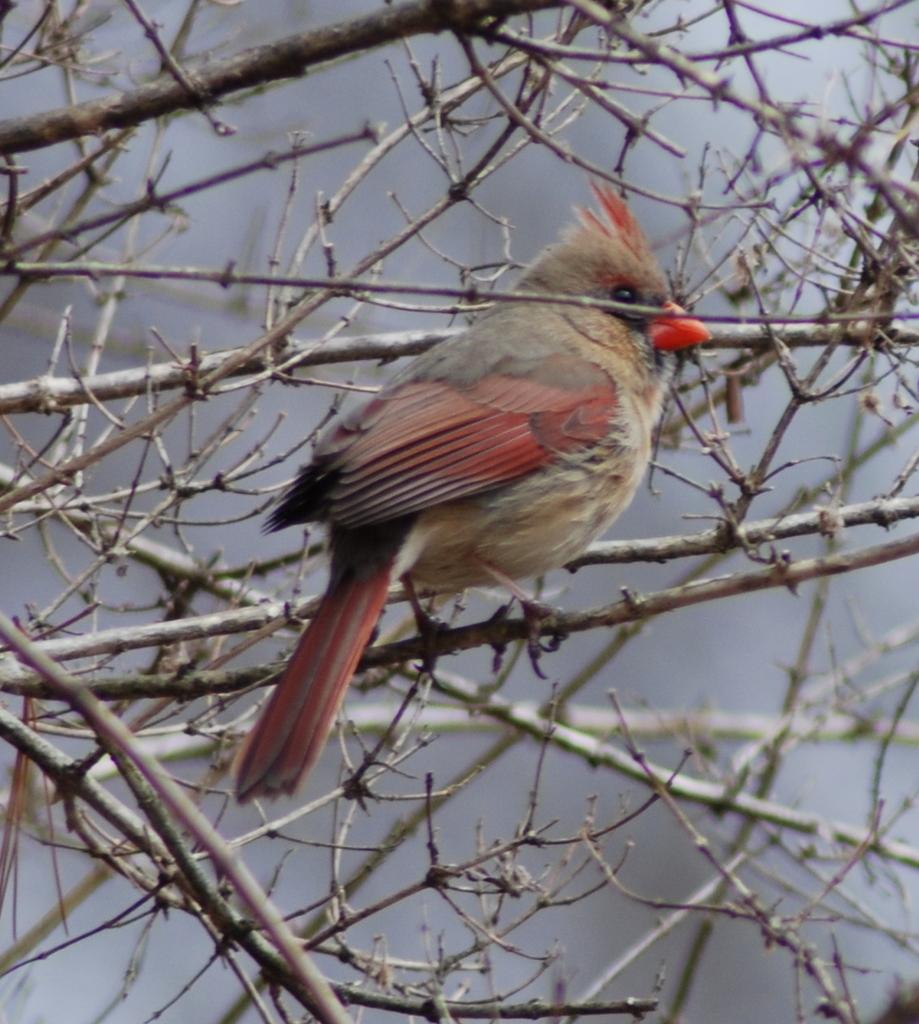Could you give a brief overview of what you see in this image? In the middle of the image we can see a bird on the branch. 